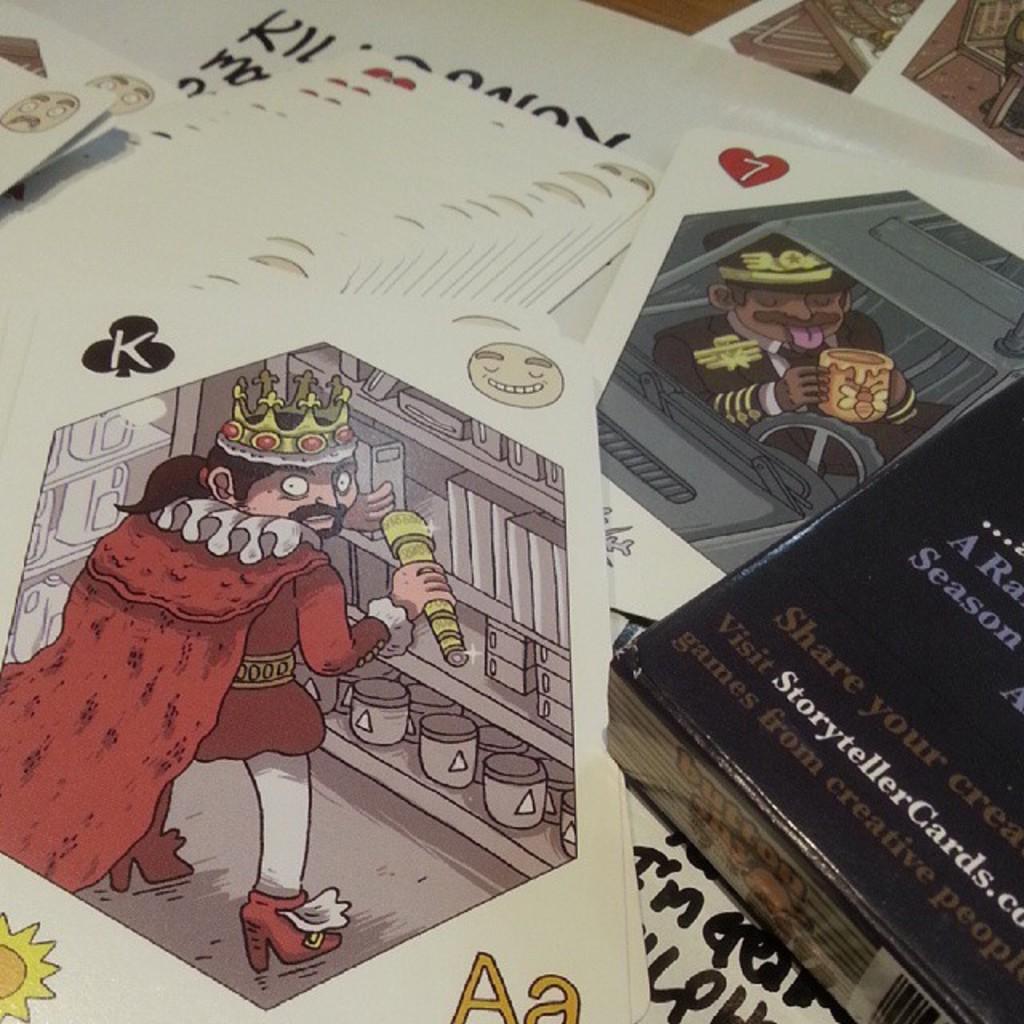What is the website listed on the black book?
Give a very brief answer. Storytellercards.com. What is from creative people?
Ensure brevity in your answer.  Games. 